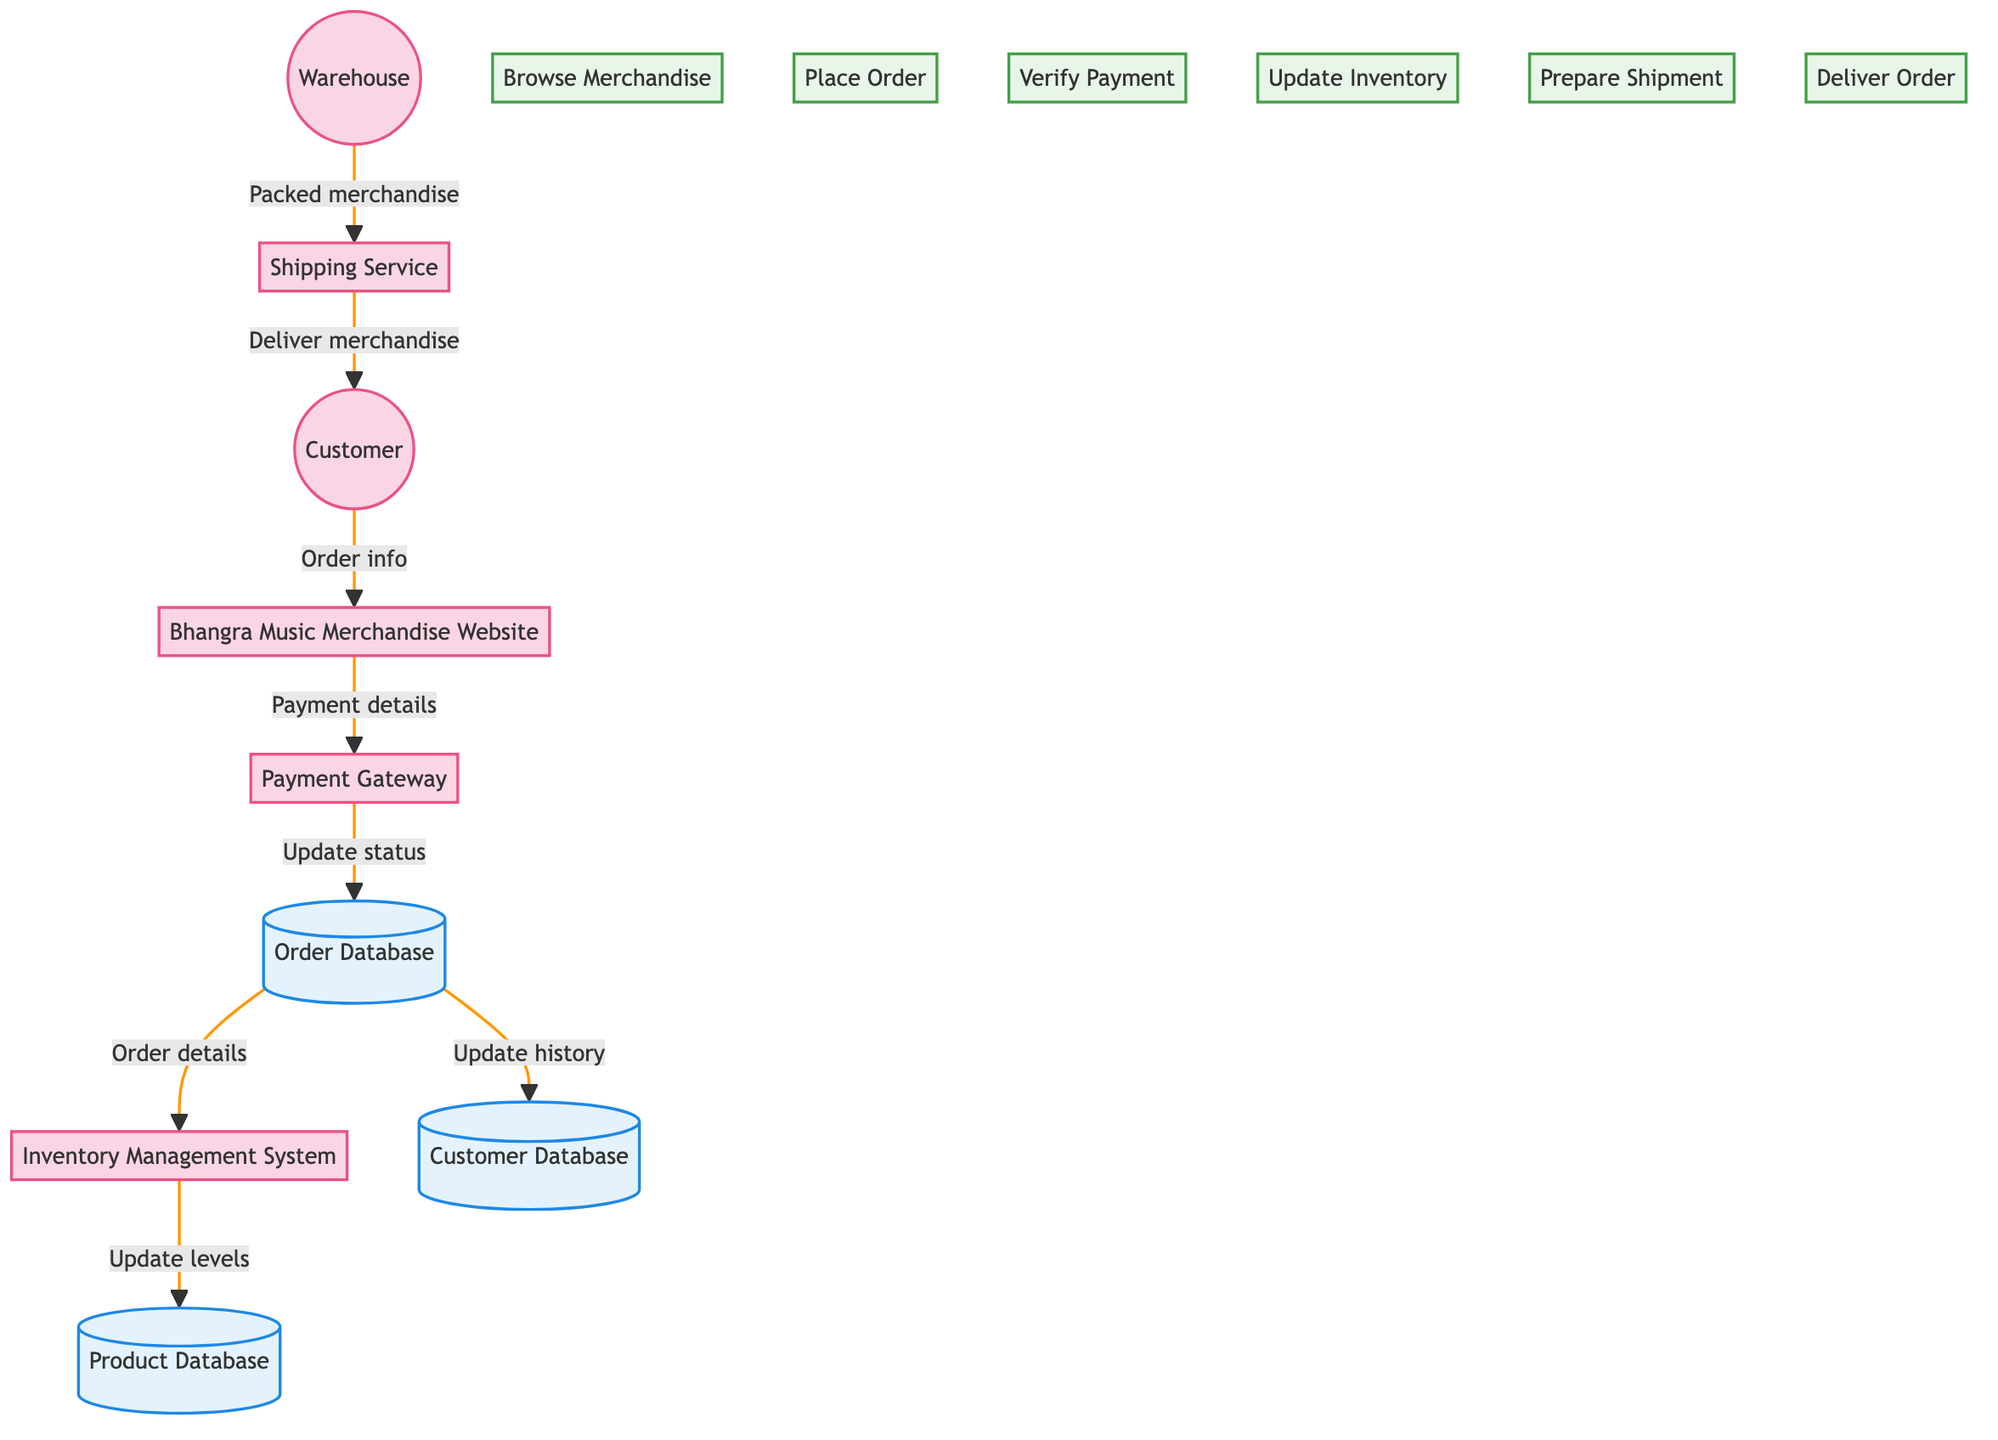What is the starting point in the flow? The starting point in the flow is the Customer, who initiates the process by providing order information to the Bhangra Music Merchandise Website.
Answer: Customer How many entities are present in the diagram? The diagram contains six entities: Customer, Bhangra Music Merchandise Website, Inventory Management System, Payment Gateway, Warehouse, and Shipping Service.
Answer: Six What does the Payment Gateway update? The Payment Gateway updates the Order Database with the payment status after verification of the customer's payment.
Answer: Order status Which entity handles the delivery of merchandise? The entity responsible for handling the delivery of merchandise is the Shipping Service.
Answer: Shipping Service What flow comes after the Order Database updates the Inventory Management System? After the Order Database updates the Inventory Management System, the flow continues to update the Product Database with the adjusted inventory levels.
Answer: Update levels Which process does the Customer start? The process that the Customer starts is "Browse Merchandise" by viewing the available items on the Bhangra Music Merchandise Website.
Answer: Browse Merchandise How many processes are defined in the diagram? There are six processes defined in the diagram: Browse Merchandise, Place Order, Verify Payment, Update Inventory, Prepare Shipment, and Deliver Order.
Answer: Six What does the Warehouse send to the Shipping Service? The Warehouse sends the packed merchandise to the Shipping Service for delivery to the customer.
Answer: Packed merchandise What is updated after the payment has been verified? After the payment has been verified, the Order Database is updated with the new order status reflecting the successful payment.
Answer: Order Database 